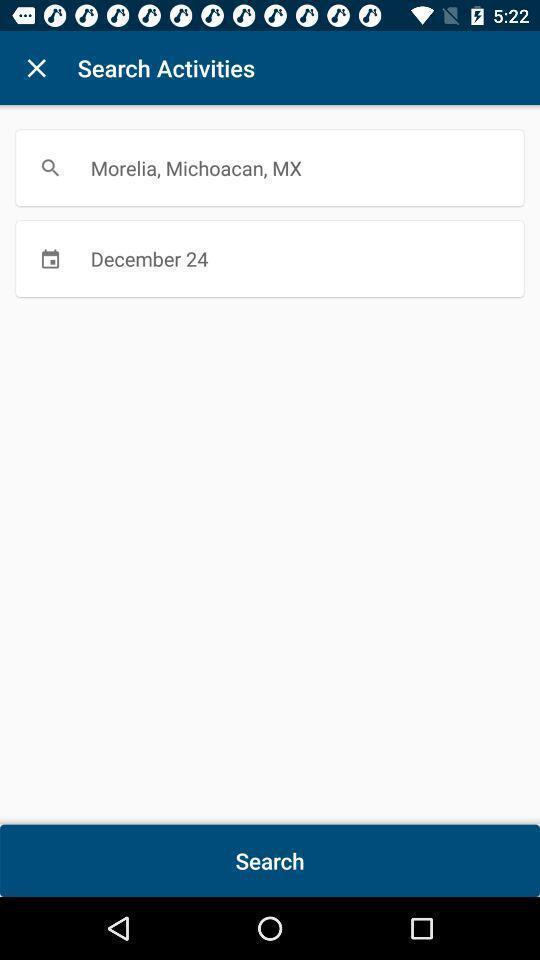Provide a textual representation of this image. Search bar option page of a travel app. 